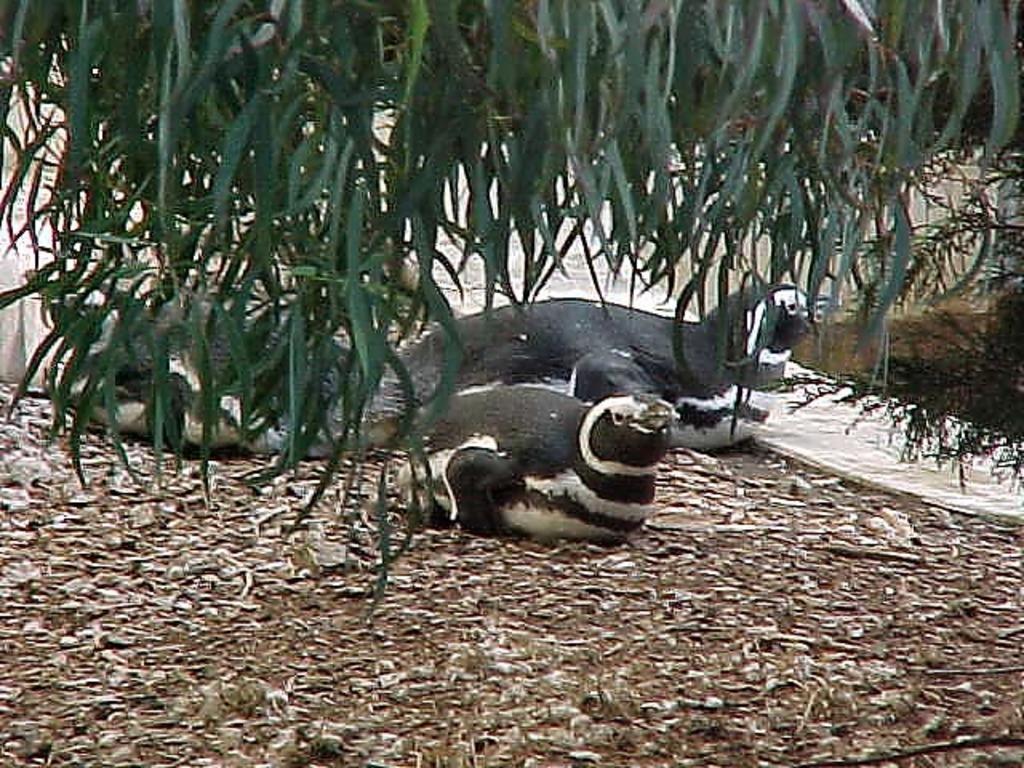Describe this image in one or two sentences. In this picture we can see seals, there is a tree in the front, at the bottom there are some leaves. 